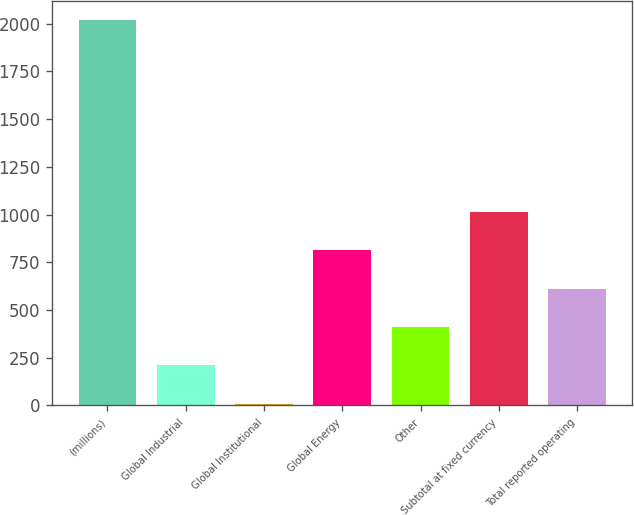<chart> <loc_0><loc_0><loc_500><loc_500><bar_chart><fcel>(millions)<fcel>Global Industrial<fcel>Global Institutional<fcel>Global Energy<fcel>Other<fcel>Subtotal at fixed currency<fcel>Total reported operating<nl><fcel>2016<fcel>210.6<fcel>10<fcel>812.4<fcel>411.2<fcel>1013<fcel>611.8<nl></chart> 